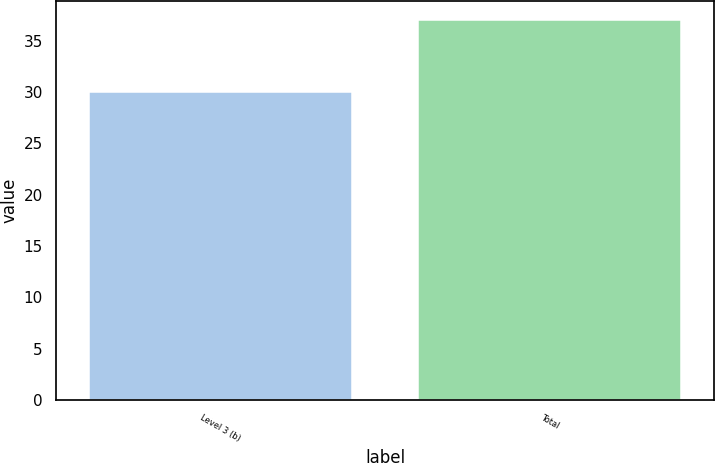<chart> <loc_0><loc_0><loc_500><loc_500><bar_chart><fcel>Level 3 (b)<fcel>Total<nl><fcel>30<fcel>37<nl></chart> 